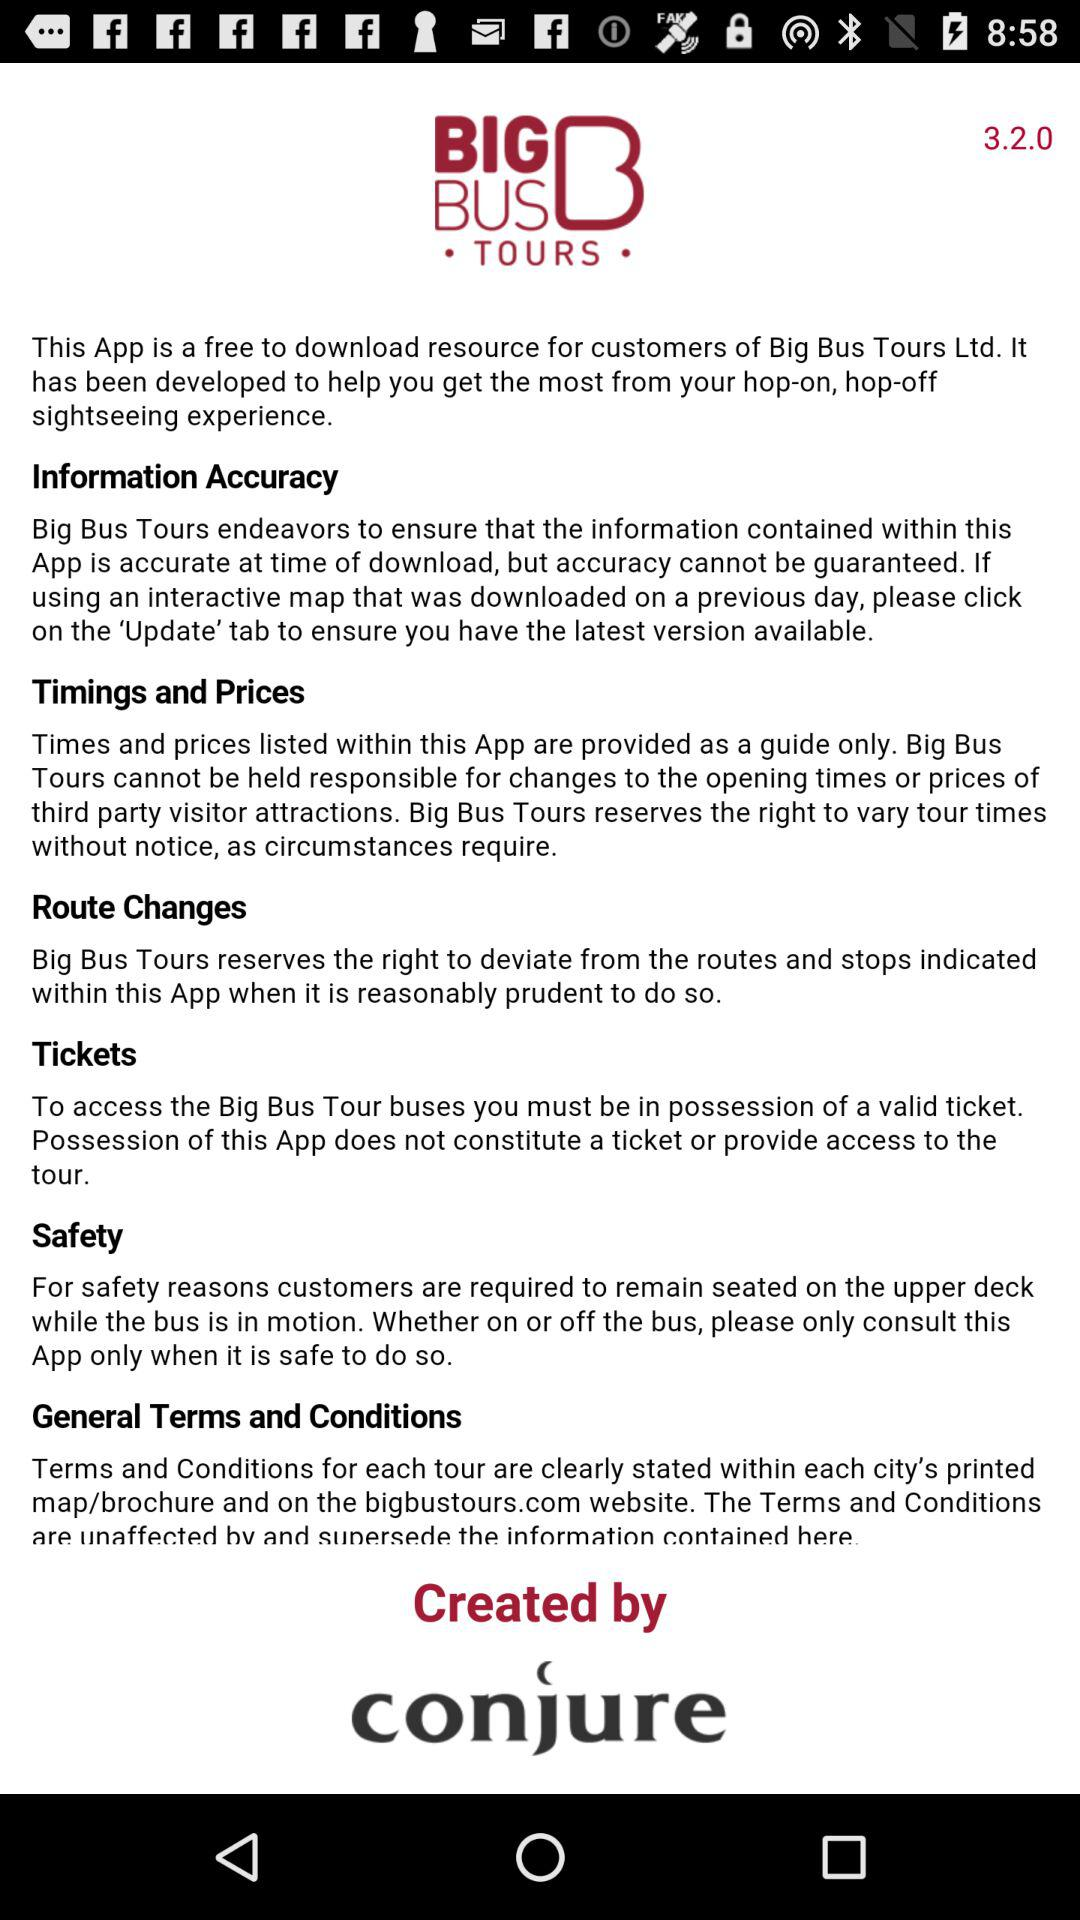What is the description for "BIG BUS TOURS" timings and prices? The description is "Times and prices listed within this App are provided as a guide only. Big Bus Tours cannot be held responsible for changes to the opening times or prices of third party visitor attractions. Big Bus Tours reserves the right to vary tour times without notice, as circumstances require.". 